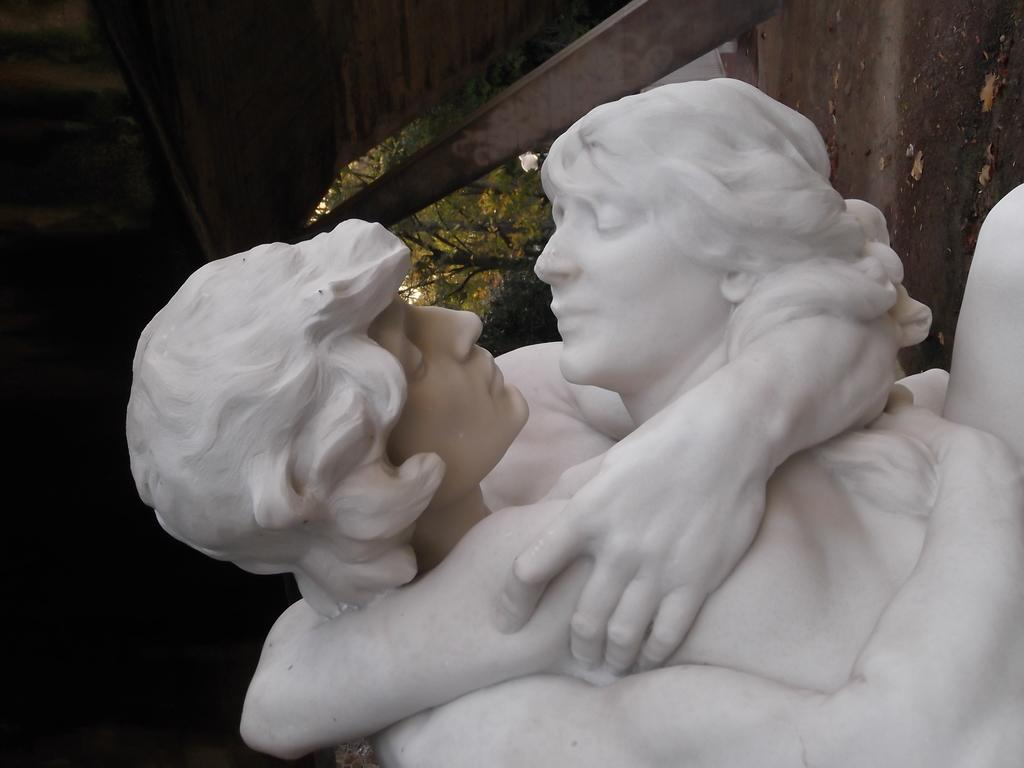What is the main subject of the image? The main subject of the image is a statue of two persons hugging. What is the color of the statue? The statue is white in color. What can be seen in the background of the image? The background of the image is dark, and there are trees visible in the background. What type of fang can be seen in the image? There is no fang present in the image; it features a statue of two persons hugging. How is the rake being used in the image? There is no rake present in the image. 